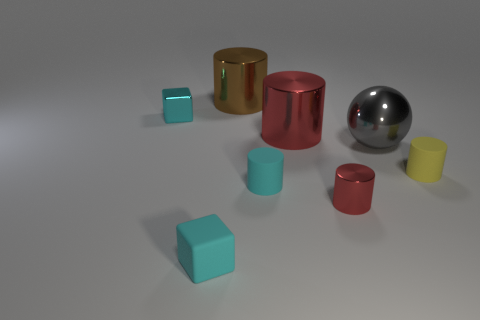There is a large gray metal object; is its shape the same as the red shiny thing left of the small red cylinder?
Provide a short and direct response. No. What is the shape of the shiny object that is the same color as the tiny shiny cylinder?
Provide a succinct answer. Cylinder. There is a small cyan object that is to the right of the cyan matte object that is left of the big brown object; how many rubber objects are in front of it?
Make the answer very short. 1. There is a metallic block that is the same size as the rubber block; what color is it?
Keep it short and to the point. Cyan. What size is the rubber thing to the right of the red object left of the small red thing?
Keep it short and to the point. Small. There is a matte cylinder that is the same color as the small rubber block; what size is it?
Make the answer very short. Small. What number of other things are there of the same size as the yellow cylinder?
Your answer should be compact. 4. What number of large brown shiny cubes are there?
Provide a short and direct response. 0. Does the gray shiny sphere have the same size as the matte cube?
Your response must be concise. No. What number of other things are there of the same shape as the tiny yellow matte thing?
Keep it short and to the point. 4. 